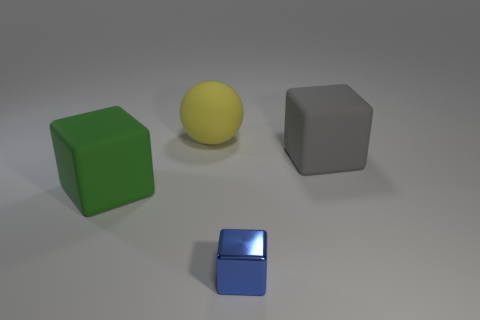Could you infer what the objects may be used for in this setting? The objects appear to be placed in an orderly manner for display or study, possibly for a visual analysis or a demonstration of geometric forms and colors. Their pristine condition and simple arrangement suggest they might be teaching tools or elements in some form of design or art composition. 